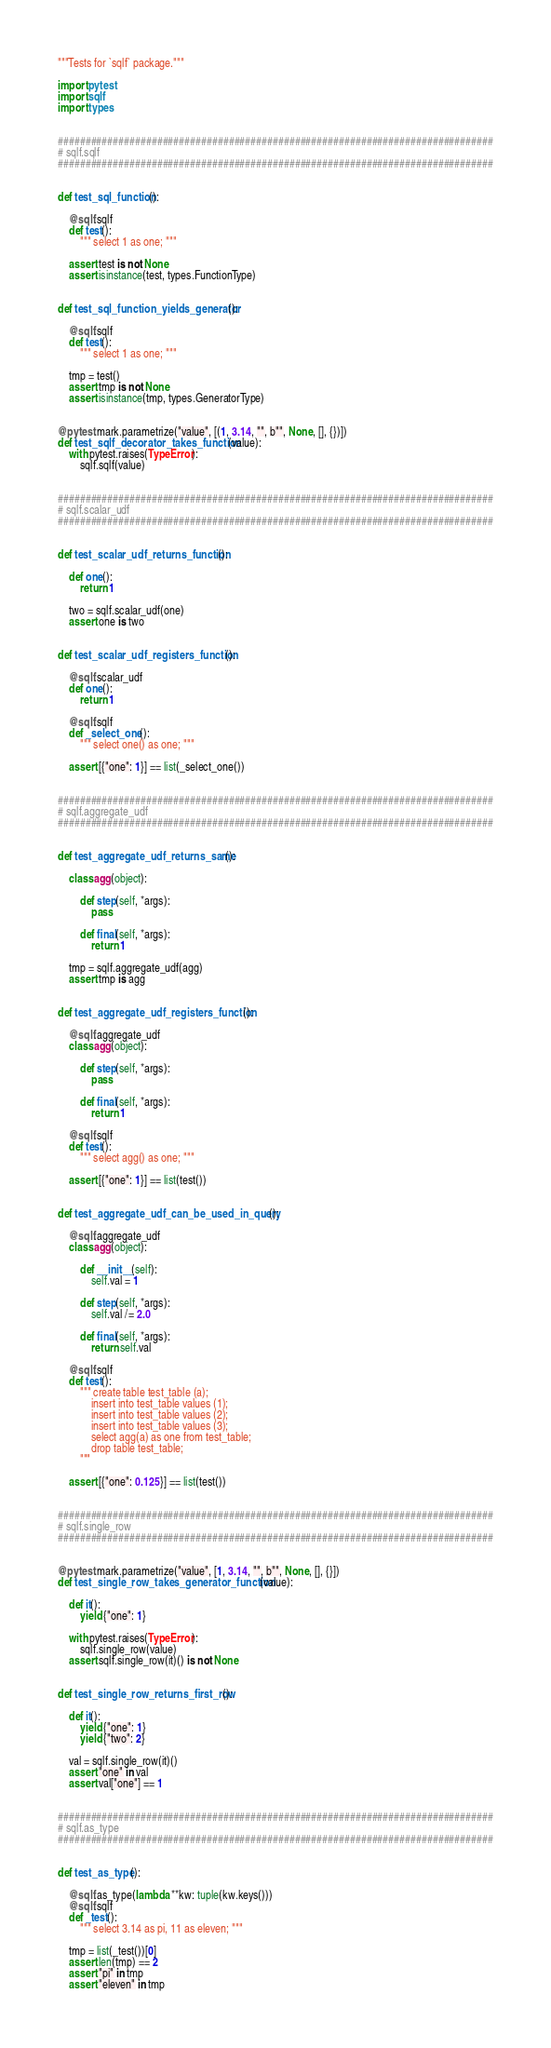Convert code to text. <code><loc_0><loc_0><loc_500><loc_500><_Python_>
"""Tests for `sqlf` package."""

import pytest
import sqlf
import types


###############################################################################
# sqlf.sqlf
###############################################################################


def test_sql_function():

    @sqlf.sqlf
    def test():
        """ select 1 as one; """

    assert test is not None
    assert isinstance(test, types.FunctionType)


def test_sql_function_yields_generator():

    @sqlf.sqlf
    def test():
        """ select 1 as one; """

    tmp = test()
    assert tmp is not None
    assert isinstance(tmp, types.GeneratorType)


@pytest.mark.parametrize("value", [(1, 3.14, "", b"", None, [], {})])
def test_sqlf_decorator_takes_function(value):
    with pytest.raises(TypeError):
        sqlf.sqlf(value)


###############################################################################
# sqlf.scalar_udf
###############################################################################


def test_scalar_udf_returns_function():

    def one():
        return 1

    two = sqlf.scalar_udf(one)
    assert one is two


def test_scalar_udf_registers_function():

    @sqlf.scalar_udf
    def one():
        return 1

    @sqlf.sqlf
    def _select_one():
        """ select one() as one; """

    assert [{"one": 1}] == list(_select_one())


###############################################################################
# sqlf.aggregate_udf
###############################################################################


def test_aggregate_udf_returns_same():

    class agg(object):

        def step(self, *args):
            pass

        def final(self, *args):
            return 1

    tmp = sqlf.aggregate_udf(agg)
    assert tmp is agg


def test_aggregate_udf_registers_function():

    @sqlf.aggregate_udf
    class agg(object):

        def step(self, *args):
            pass

        def final(self, *args):
            return 1

    @sqlf.sqlf
    def test():
        """ select agg() as one; """

    assert [{"one": 1}] == list(test())


def test_aggregate_udf_can_be_used_in_query():

    @sqlf.aggregate_udf
    class agg(object):

        def __init__(self):
            self.val = 1

        def step(self, *args):
            self.val /= 2.0

        def final(self, *args):
            return self.val

    @sqlf.sqlf
    def test():
        """ create table test_table (a);
            insert into test_table values (1);
            insert into test_table values (2);
            insert into test_table values (3);
            select agg(a) as one from test_table;
            drop table test_table;
        """

    assert [{"one": 0.125}] == list(test())


###############################################################################
# sqlf.single_row
###############################################################################


@pytest.mark.parametrize("value", [1, 3.14, "", b"", None, [], {}])
def test_single_row_takes_generator_function(value):

    def it():
        yield {"one": 1}

    with pytest.raises(TypeError):
        sqlf.single_row(value)
    assert sqlf.single_row(it)() is not None


def test_single_row_returns_first_row():

    def it():
        yield {"one": 1}
        yield {"two": 2}

    val = sqlf.single_row(it)()
    assert "one" in val
    assert val["one"] == 1


###############################################################################
# sqlf.as_type
###############################################################################


def test_as_type():

    @sqlf.as_type(lambda **kw: tuple(kw.keys()))
    @sqlf.sqlf
    def _test():
        """ select 3.14 as pi, 11 as eleven; """

    tmp = list(_test())[0]
    assert len(tmp) == 2
    assert "pi" in tmp
    assert "eleven" in tmp
</code> 